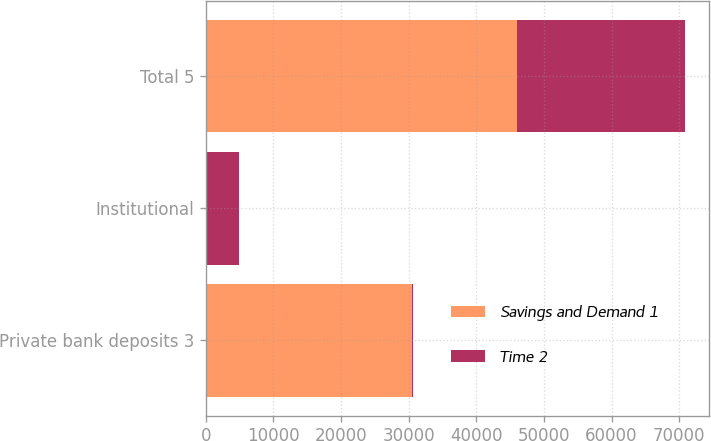<chart> <loc_0><loc_0><loc_500><loc_500><stacked_bar_chart><ecel><fcel>Private bank deposits 3<fcel>Institutional<fcel>Total 5<nl><fcel>Savings and Demand 1<fcel>30475<fcel>33<fcel>46019<nl><fcel>Time 2<fcel>212<fcel>4867<fcel>24788<nl></chart> 